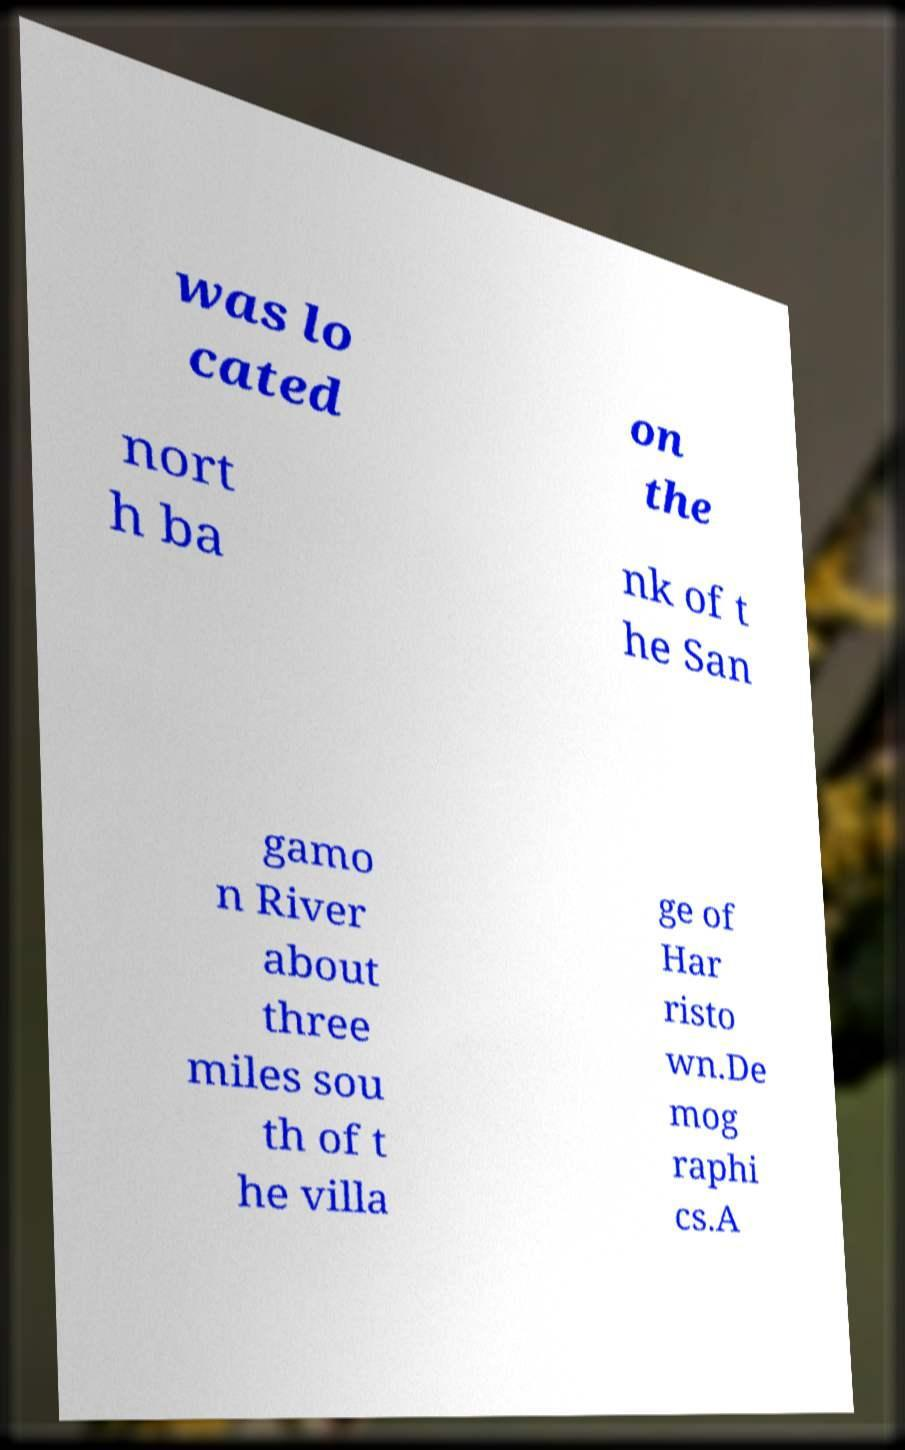I need the written content from this picture converted into text. Can you do that? was lo cated on the nort h ba nk of t he San gamo n River about three miles sou th of t he villa ge of Har risto wn.De mog raphi cs.A 